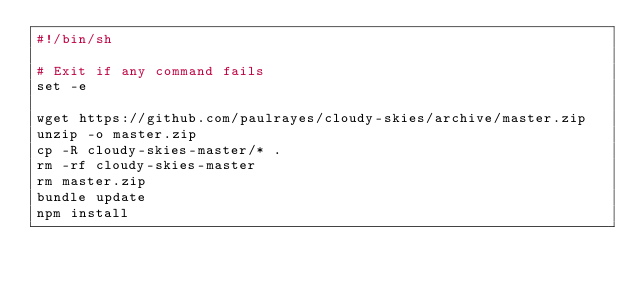<code> <loc_0><loc_0><loc_500><loc_500><_Bash_>#!/bin/sh

# Exit if any command fails
set -e

wget https://github.com/paulrayes/cloudy-skies/archive/master.zip
unzip -o master.zip
cp -R cloudy-skies-master/* .
rm -rf cloudy-skies-master
rm master.zip
bundle update
npm install
</code> 